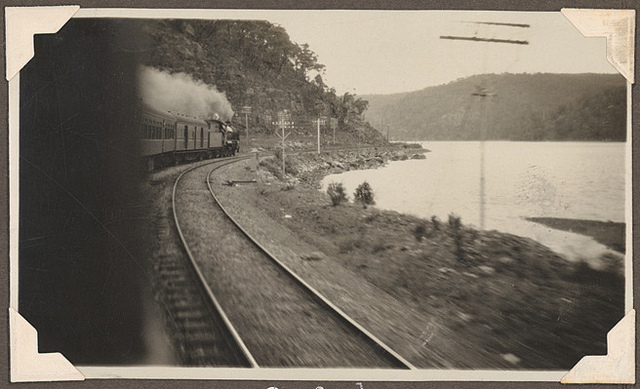<image>What is this train commemorating? I don't know what the train is commemorating. It could be '50 years of service', 'travel', 'olden times', 'annual celebration', or 'presidents day'. What is this train commemorating? I don't know what this train is commemorating. It can be any of the given options. 